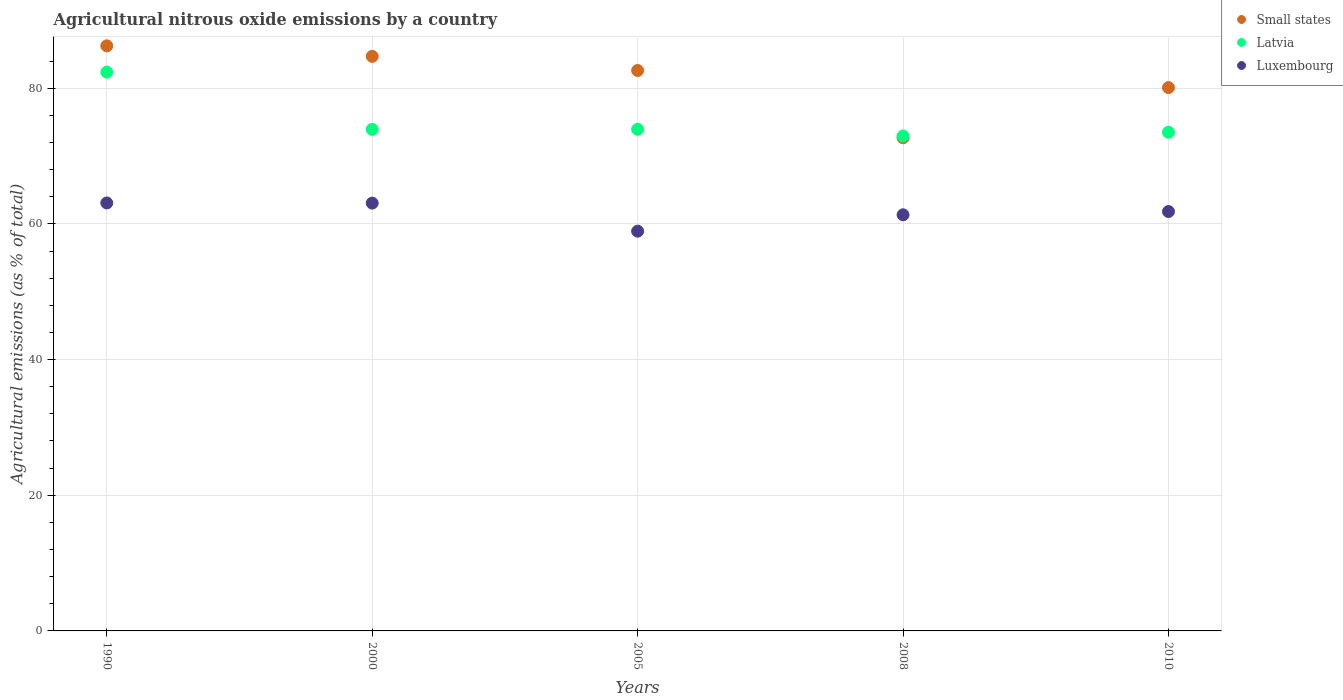How many different coloured dotlines are there?
Your response must be concise. 3. What is the amount of agricultural nitrous oxide emitted in Small states in 2010?
Keep it short and to the point. 80.09. Across all years, what is the maximum amount of agricultural nitrous oxide emitted in Small states?
Ensure brevity in your answer.  86.24. Across all years, what is the minimum amount of agricultural nitrous oxide emitted in Small states?
Ensure brevity in your answer.  72.7. What is the total amount of agricultural nitrous oxide emitted in Luxembourg in the graph?
Offer a very short reply. 308.23. What is the difference between the amount of agricultural nitrous oxide emitted in Luxembourg in 2000 and that in 2005?
Keep it short and to the point. 4.14. What is the difference between the amount of agricultural nitrous oxide emitted in Small states in 2008 and the amount of agricultural nitrous oxide emitted in Luxembourg in 2010?
Make the answer very short. 10.88. What is the average amount of agricultural nitrous oxide emitted in Latvia per year?
Provide a short and direct response. 75.34. In the year 2000, what is the difference between the amount of agricultural nitrous oxide emitted in Small states and amount of agricultural nitrous oxide emitted in Luxembourg?
Offer a terse response. 21.63. In how many years, is the amount of agricultural nitrous oxide emitted in Luxembourg greater than 56 %?
Ensure brevity in your answer.  5. What is the ratio of the amount of agricultural nitrous oxide emitted in Small states in 1990 to that in 2000?
Give a very brief answer. 1.02. Is the amount of agricultural nitrous oxide emitted in Latvia in 2005 less than that in 2008?
Keep it short and to the point. No. Is the difference between the amount of agricultural nitrous oxide emitted in Small states in 2005 and 2010 greater than the difference between the amount of agricultural nitrous oxide emitted in Luxembourg in 2005 and 2010?
Your answer should be compact. Yes. What is the difference between the highest and the second highest amount of agricultural nitrous oxide emitted in Latvia?
Ensure brevity in your answer.  8.43. What is the difference between the highest and the lowest amount of agricultural nitrous oxide emitted in Luxembourg?
Keep it short and to the point. 4.16. In how many years, is the amount of agricultural nitrous oxide emitted in Small states greater than the average amount of agricultural nitrous oxide emitted in Small states taken over all years?
Keep it short and to the point. 3. Is the sum of the amount of agricultural nitrous oxide emitted in Luxembourg in 1990 and 2010 greater than the maximum amount of agricultural nitrous oxide emitted in Latvia across all years?
Provide a short and direct response. Yes. Is it the case that in every year, the sum of the amount of agricultural nitrous oxide emitted in Small states and amount of agricultural nitrous oxide emitted in Luxembourg  is greater than the amount of agricultural nitrous oxide emitted in Latvia?
Provide a succinct answer. Yes. Does the amount of agricultural nitrous oxide emitted in Small states monotonically increase over the years?
Give a very brief answer. No. Is the amount of agricultural nitrous oxide emitted in Small states strictly less than the amount of agricultural nitrous oxide emitted in Luxembourg over the years?
Ensure brevity in your answer.  No. How many dotlines are there?
Make the answer very short. 3. How many years are there in the graph?
Make the answer very short. 5. What is the difference between two consecutive major ticks on the Y-axis?
Your response must be concise. 20. Where does the legend appear in the graph?
Your answer should be compact. Top right. How many legend labels are there?
Provide a succinct answer. 3. What is the title of the graph?
Provide a short and direct response. Agricultural nitrous oxide emissions by a country. What is the label or title of the Y-axis?
Offer a terse response. Agricultural emissions (as % of total). What is the Agricultural emissions (as % of total) in Small states in 1990?
Provide a succinct answer. 86.24. What is the Agricultural emissions (as % of total) in Latvia in 1990?
Your response must be concise. 82.37. What is the Agricultural emissions (as % of total) in Luxembourg in 1990?
Your answer should be compact. 63.08. What is the Agricultural emissions (as % of total) in Small states in 2000?
Your answer should be compact. 84.69. What is the Agricultural emissions (as % of total) in Latvia in 2000?
Keep it short and to the point. 73.93. What is the Agricultural emissions (as % of total) in Luxembourg in 2000?
Your response must be concise. 63.06. What is the Agricultural emissions (as % of total) in Small states in 2005?
Your response must be concise. 82.61. What is the Agricultural emissions (as % of total) of Latvia in 2005?
Provide a short and direct response. 73.94. What is the Agricultural emissions (as % of total) of Luxembourg in 2005?
Ensure brevity in your answer.  58.93. What is the Agricultural emissions (as % of total) of Small states in 2008?
Offer a terse response. 72.7. What is the Agricultural emissions (as % of total) in Latvia in 2008?
Your answer should be very brief. 72.96. What is the Agricultural emissions (as % of total) in Luxembourg in 2008?
Ensure brevity in your answer.  61.34. What is the Agricultural emissions (as % of total) in Small states in 2010?
Your answer should be very brief. 80.09. What is the Agricultural emissions (as % of total) of Latvia in 2010?
Provide a succinct answer. 73.51. What is the Agricultural emissions (as % of total) in Luxembourg in 2010?
Ensure brevity in your answer.  61.82. Across all years, what is the maximum Agricultural emissions (as % of total) in Small states?
Your answer should be very brief. 86.24. Across all years, what is the maximum Agricultural emissions (as % of total) in Latvia?
Make the answer very short. 82.37. Across all years, what is the maximum Agricultural emissions (as % of total) in Luxembourg?
Give a very brief answer. 63.08. Across all years, what is the minimum Agricultural emissions (as % of total) of Small states?
Keep it short and to the point. 72.7. Across all years, what is the minimum Agricultural emissions (as % of total) of Latvia?
Offer a very short reply. 72.96. Across all years, what is the minimum Agricultural emissions (as % of total) of Luxembourg?
Make the answer very short. 58.93. What is the total Agricultural emissions (as % of total) in Small states in the graph?
Your answer should be compact. 406.33. What is the total Agricultural emissions (as % of total) of Latvia in the graph?
Provide a succinct answer. 376.71. What is the total Agricultural emissions (as % of total) of Luxembourg in the graph?
Your response must be concise. 308.23. What is the difference between the Agricultural emissions (as % of total) of Small states in 1990 and that in 2000?
Your response must be concise. 1.55. What is the difference between the Agricultural emissions (as % of total) of Latvia in 1990 and that in 2000?
Give a very brief answer. 8.45. What is the difference between the Agricultural emissions (as % of total) of Luxembourg in 1990 and that in 2000?
Keep it short and to the point. 0.02. What is the difference between the Agricultural emissions (as % of total) in Small states in 1990 and that in 2005?
Ensure brevity in your answer.  3.64. What is the difference between the Agricultural emissions (as % of total) in Latvia in 1990 and that in 2005?
Offer a terse response. 8.43. What is the difference between the Agricultural emissions (as % of total) of Luxembourg in 1990 and that in 2005?
Your response must be concise. 4.16. What is the difference between the Agricultural emissions (as % of total) of Small states in 1990 and that in 2008?
Give a very brief answer. 13.55. What is the difference between the Agricultural emissions (as % of total) of Latvia in 1990 and that in 2008?
Offer a terse response. 9.42. What is the difference between the Agricultural emissions (as % of total) in Luxembourg in 1990 and that in 2008?
Give a very brief answer. 1.75. What is the difference between the Agricultural emissions (as % of total) of Small states in 1990 and that in 2010?
Offer a very short reply. 6.16. What is the difference between the Agricultural emissions (as % of total) in Latvia in 1990 and that in 2010?
Provide a succinct answer. 8.87. What is the difference between the Agricultural emissions (as % of total) of Luxembourg in 1990 and that in 2010?
Offer a very short reply. 1.26. What is the difference between the Agricultural emissions (as % of total) of Small states in 2000 and that in 2005?
Your answer should be compact. 2.09. What is the difference between the Agricultural emissions (as % of total) in Latvia in 2000 and that in 2005?
Your answer should be compact. -0.02. What is the difference between the Agricultural emissions (as % of total) in Luxembourg in 2000 and that in 2005?
Your answer should be very brief. 4.14. What is the difference between the Agricultural emissions (as % of total) of Small states in 2000 and that in 2008?
Your answer should be compact. 12. What is the difference between the Agricultural emissions (as % of total) of Latvia in 2000 and that in 2008?
Offer a very short reply. 0.97. What is the difference between the Agricultural emissions (as % of total) of Luxembourg in 2000 and that in 2008?
Your answer should be very brief. 1.73. What is the difference between the Agricultural emissions (as % of total) of Small states in 2000 and that in 2010?
Offer a terse response. 4.61. What is the difference between the Agricultural emissions (as % of total) in Latvia in 2000 and that in 2010?
Provide a succinct answer. 0.42. What is the difference between the Agricultural emissions (as % of total) of Luxembourg in 2000 and that in 2010?
Offer a terse response. 1.24. What is the difference between the Agricultural emissions (as % of total) in Small states in 2005 and that in 2008?
Your response must be concise. 9.91. What is the difference between the Agricultural emissions (as % of total) of Latvia in 2005 and that in 2008?
Provide a short and direct response. 0.99. What is the difference between the Agricultural emissions (as % of total) in Luxembourg in 2005 and that in 2008?
Make the answer very short. -2.41. What is the difference between the Agricultural emissions (as % of total) of Small states in 2005 and that in 2010?
Ensure brevity in your answer.  2.52. What is the difference between the Agricultural emissions (as % of total) in Latvia in 2005 and that in 2010?
Offer a very short reply. 0.44. What is the difference between the Agricultural emissions (as % of total) of Luxembourg in 2005 and that in 2010?
Your response must be concise. -2.89. What is the difference between the Agricultural emissions (as % of total) in Small states in 2008 and that in 2010?
Ensure brevity in your answer.  -7.39. What is the difference between the Agricultural emissions (as % of total) in Latvia in 2008 and that in 2010?
Ensure brevity in your answer.  -0.55. What is the difference between the Agricultural emissions (as % of total) of Luxembourg in 2008 and that in 2010?
Give a very brief answer. -0.48. What is the difference between the Agricultural emissions (as % of total) of Small states in 1990 and the Agricultural emissions (as % of total) of Latvia in 2000?
Give a very brief answer. 12.32. What is the difference between the Agricultural emissions (as % of total) in Small states in 1990 and the Agricultural emissions (as % of total) in Luxembourg in 2000?
Make the answer very short. 23.18. What is the difference between the Agricultural emissions (as % of total) of Latvia in 1990 and the Agricultural emissions (as % of total) of Luxembourg in 2000?
Your answer should be very brief. 19.31. What is the difference between the Agricultural emissions (as % of total) of Small states in 1990 and the Agricultural emissions (as % of total) of Latvia in 2005?
Make the answer very short. 12.3. What is the difference between the Agricultural emissions (as % of total) in Small states in 1990 and the Agricultural emissions (as % of total) in Luxembourg in 2005?
Your answer should be very brief. 27.32. What is the difference between the Agricultural emissions (as % of total) of Latvia in 1990 and the Agricultural emissions (as % of total) of Luxembourg in 2005?
Ensure brevity in your answer.  23.45. What is the difference between the Agricultural emissions (as % of total) of Small states in 1990 and the Agricultural emissions (as % of total) of Latvia in 2008?
Keep it short and to the point. 13.29. What is the difference between the Agricultural emissions (as % of total) in Small states in 1990 and the Agricultural emissions (as % of total) in Luxembourg in 2008?
Your answer should be very brief. 24.91. What is the difference between the Agricultural emissions (as % of total) of Latvia in 1990 and the Agricultural emissions (as % of total) of Luxembourg in 2008?
Ensure brevity in your answer.  21.04. What is the difference between the Agricultural emissions (as % of total) of Small states in 1990 and the Agricultural emissions (as % of total) of Latvia in 2010?
Keep it short and to the point. 12.74. What is the difference between the Agricultural emissions (as % of total) in Small states in 1990 and the Agricultural emissions (as % of total) in Luxembourg in 2010?
Offer a very short reply. 24.42. What is the difference between the Agricultural emissions (as % of total) in Latvia in 1990 and the Agricultural emissions (as % of total) in Luxembourg in 2010?
Your response must be concise. 20.55. What is the difference between the Agricultural emissions (as % of total) of Small states in 2000 and the Agricultural emissions (as % of total) of Latvia in 2005?
Make the answer very short. 10.75. What is the difference between the Agricultural emissions (as % of total) in Small states in 2000 and the Agricultural emissions (as % of total) in Luxembourg in 2005?
Keep it short and to the point. 25.77. What is the difference between the Agricultural emissions (as % of total) in Latvia in 2000 and the Agricultural emissions (as % of total) in Luxembourg in 2005?
Offer a terse response. 15. What is the difference between the Agricultural emissions (as % of total) in Small states in 2000 and the Agricultural emissions (as % of total) in Latvia in 2008?
Offer a very short reply. 11.74. What is the difference between the Agricultural emissions (as % of total) of Small states in 2000 and the Agricultural emissions (as % of total) of Luxembourg in 2008?
Offer a terse response. 23.36. What is the difference between the Agricultural emissions (as % of total) of Latvia in 2000 and the Agricultural emissions (as % of total) of Luxembourg in 2008?
Ensure brevity in your answer.  12.59. What is the difference between the Agricultural emissions (as % of total) in Small states in 2000 and the Agricultural emissions (as % of total) in Latvia in 2010?
Your answer should be very brief. 11.19. What is the difference between the Agricultural emissions (as % of total) of Small states in 2000 and the Agricultural emissions (as % of total) of Luxembourg in 2010?
Give a very brief answer. 22.87. What is the difference between the Agricultural emissions (as % of total) of Latvia in 2000 and the Agricultural emissions (as % of total) of Luxembourg in 2010?
Provide a succinct answer. 12.11. What is the difference between the Agricultural emissions (as % of total) in Small states in 2005 and the Agricultural emissions (as % of total) in Latvia in 2008?
Ensure brevity in your answer.  9.65. What is the difference between the Agricultural emissions (as % of total) of Small states in 2005 and the Agricultural emissions (as % of total) of Luxembourg in 2008?
Make the answer very short. 21.27. What is the difference between the Agricultural emissions (as % of total) in Latvia in 2005 and the Agricultural emissions (as % of total) in Luxembourg in 2008?
Make the answer very short. 12.61. What is the difference between the Agricultural emissions (as % of total) of Small states in 2005 and the Agricultural emissions (as % of total) of Latvia in 2010?
Make the answer very short. 9.1. What is the difference between the Agricultural emissions (as % of total) in Small states in 2005 and the Agricultural emissions (as % of total) in Luxembourg in 2010?
Keep it short and to the point. 20.79. What is the difference between the Agricultural emissions (as % of total) of Latvia in 2005 and the Agricultural emissions (as % of total) of Luxembourg in 2010?
Offer a terse response. 12.12. What is the difference between the Agricultural emissions (as % of total) of Small states in 2008 and the Agricultural emissions (as % of total) of Latvia in 2010?
Provide a short and direct response. -0.81. What is the difference between the Agricultural emissions (as % of total) of Small states in 2008 and the Agricultural emissions (as % of total) of Luxembourg in 2010?
Give a very brief answer. 10.88. What is the difference between the Agricultural emissions (as % of total) of Latvia in 2008 and the Agricultural emissions (as % of total) of Luxembourg in 2010?
Provide a short and direct response. 11.14. What is the average Agricultural emissions (as % of total) of Small states per year?
Provide a succinct answer. 81.27. What is the average Agricultural emissions (as % of total) in Latvia per year?
Offer a terse response. 75.34. What is the average Agricultural emissions (as % of total) of Luxembourg per year?
Provide a short and direct response. 61.65. In the year 1990, what is the difference between the Agricultural emissions (as % of total) of Small states and Agricultural emissions (as % of total) of Latvia?
Ensure brevity in your answer.  3.87. In the year 1990, what is the difference between the Agricultural emissions (as % of total) in Small states and Agricultural emissions (as % of total) in Luxembourg?
Your response must be concise. 23.16. In the year 1990, what is the difference between the Agricultural emissions (as % of total) in Latvia and Agricultural emissions (as % of total) in Luxembourg?
Your answer should be very brief. 19.29. In the year 2000, what is the difference between the Agricultural emissions (as % of total) in Small states and Agricultural emissions (as % of total) in Latvia?
Your answer should be very brief. 10.77. In the year 2000, what is the difference between the Agricultural emissions (as % of total) of Small states and Agricultural emissions (as % of total) of Luxembourg?
Give a very brief answer. 21.63. In the year 2000, what is the difference between the Agricultural emissions (as % of total) in Latvia and Agricultural emissions (as % of total) in Luxembourg?
Keep it short and to the point. 10.86. In the year 2005, what is the difference between the Agricultural emissions (as % of total) in Small states and Agricultural emissions (as % of total) in Latvia?
Your answer should be compact. 8.66. In the year 2005, what is the difference between the Agricultural emissions (as % of total) in Small states and Agricultural emissions (as % of total) in Luxembourg?
Offer a terse response. 23.68. In the year 2005, what is the difference between the Agricultural emissions (as % of total) of Latvia and Agricultural emissions (as % of total) of Luxembourg?
Keep it short and to the point. 15.02. In the year 2008, what is the difference between the Agricultural emissions (as % of total) in Small states and Agricultural emissions (as % of total) in Latvia?
Offer a very short reply. -0.26. In the year 2008, what is the difference between the Agricultural emissions (as % of total) of Small states and Agricultural emissions (as % of total) of Luxembourg?
Make the answer very short. 11.36. In the year 2008, what is the difference between the Agricultural emissions (as % of total) of Latvia and Agricultural emissions (as % of total) of Luxembourg?
Provide a succinct answer. 11.62. In the year 2010, what is the difference between the Agricultural emissions (as % of total) in Small states and Agricultural emissions (as % of total) in Latvia?
Provide a succinct answer. 6.58. In the year 2010, what is the difference between the Agricultural emissions (as % of total) of Small states and Agricultural emissions (as % of total) of Luxembourg?
Your answer should be compact. 18.27. In the year 2010, what is the difference between the Agricultural emissions (as % of total) of Latvia and Agricultural emissions (as % of total) of Luxembourg?
Give a very brief answer. 11.69. What is the ratio of the Agricultural emissions (as % of total) in Small states in 1990 to that in 2000?
Provide a succinct answer. 1.02. What is the ratio of the Agricultural emissions (as % of total) in Latvia in 1990 to that in 2000?
Provide a succinct answer. 1.11. What is the ratio of the Agricultural emissions (as % of total) in Luxembourg in 1990 to that in 2000?
Offer a terse response. 1. What is the ratio of the Agricultural emissions (as % of total) in Small states in 1990 to that in 2005?
Give a very brief answer. 1.04. What is the ratio of the Agricultural emissions (as % of total) in Latvia in 1990 to that in 2005?
Your answer should be very brief. 1.11. What is the ratio of the Agricultural emissions (as % of total) in Luxembourg in 1990 to that in 2005?
Provide a short and direct response. 1.07. What is the ratio of the Agricultural emissions (as % of total) of Small states in 1990 to that in 2008?
Offer a terse response. 1.19. What is the ratio of the Agricultural emissions (as % of total) in Latvia in 1990 to that in 2008?
Your answer should be very brief. 1.13. What is the ratio of the Agricultural emissions (as % of total) in Luxembourg in 1990 to that in 2008?
Give a very brief answer. 1.03. What is the ratio of the Agricultural emissions (as % of total) in Latvia in 1990 to that in 2010?
Offer a very short reply. 1.12. What is the ratio of the Agricultural emissions (as % of total) in Luxembourg in 1990 to that in 2010?
Your response must be concise. 1.02. What is the ratio of the Agricultural emissions (as % of total) in Small states in 2000 to that in 2005?
Your response must be concise. 1.03. What is the ratio of the Agricultural emissions (as % of total) of Luxembourg in 2000 to that in 2005?
Offer a very short reply. 1.07. What is the ratio of the Agricultural emissions (as % of total) in Small states in 2000 to that in 2008?
Make the answer very short. 1.17. What is the ratio of the Agricultural emissions (as % of total) in Latvia in 2000 to that in 2008?
Your answer should be very brief. 1.01. What is the ratio of the Agricultural emissions (as % of total) in Luxembourg in 2000 to that in 2008?
Ensure brevity in your answer.  1.03. What is the ratio of the Agricultural emissions (as % of total) of Small states in 2000 to that in 2010?
Offer a terse response. 1.06. What is the ratio of the Agricultural emissions (as % of total) in Luxembourg in 2000 to that in 2010?
Offer a very short reply. 1.02. What is the ratio of the Agricultural emissions (as % of total) in Small states in 2005 to that in 2008?
Ensure brevity in your answer.  1.14. What is the ratio of the Agricultural emissions (as % of total) of Latvia in 2005 to that in 2008?
Keep it short and to the point. 1.01. What is the ratio of the Agricultural emissions (as % of total) of Luxembourg in 2005 to that in 2008?
Provide a succinct answer. 0.96. What is the ratio of the Agricultural emissions (as % of total) in Small states in 2005 to that in 2010?
Make the answer very short. 1.03. What is the ratio of the Agricultural emissions (as % of total) of Latvia in 2005 to that in 2010?
Your response must be concise. 1.01. What is the ratio of the Agricultural emissions (as % of total) in Luxembourg in 2005 to that in 2010?
Give a very brief answer. 0.95. What is the ratio of the Agricultural emissions (as % of total) of Small states in 2008 to that in 2010?
Offer a very short reply. 0.91. What is the ratio of the Agricultural emissions (as % of total) in Luxembourg in 2008 to that in 2010?
Keep it short and to the point. 0.99. What is the difference between the highest and the second highest Agricultural emissions (as % of total) of Small states?
Make the answer very short. 1.55. What is the difference between the highest and the second highest Agricultural emissions (as % of total) in Latvia?
Offer a very short reply. 8.43. What is the difference between the highest and the second highest Agricultural emissions (as % of total) of Luxembourg?
Offer a terse response. 0.02. What is the difference between the highest and the lowest Agricultural emissions (as % of total) of Small states?
Your answer should be compact. 13.55. What is the difference between the highest and the lowest Agricultural emissions (as % of total) in Latvia?
Give a very brief answer. 9.42. What is the difference between the highest and the lowest Agricultural emissions (as % of total) of Luxembourg?
Offer a terse response. 4.16. 